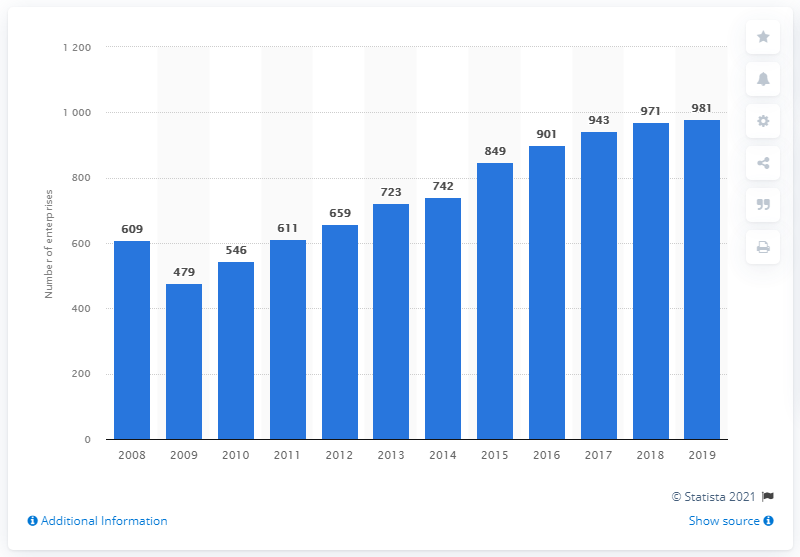Draw attention to some important aspects in this diagram. There were 479 specialist games and toys stores in the UK in 2009. 